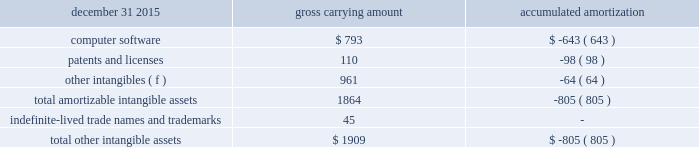December 31 , 2015 carrying amount accumulated amortization .
Computer software consists primarily of software costs associated with an enterprise business solution ( ebs ) within arconic to drive common systems among all businesses .
Amortization expense related to the intangible assets in the tables above for the years ended december 31 , 2016 , 2015 , and 2014 was $ 65 , $ 67 , and $ 55 , respectively , and is expected to be in the range of approximately $ 56 to $ 64 annually from 2017 to 2021 .
Acquisitions and divestitures pro forma results of the company , assuming all acquisitions described below were made at the beginning of the earliest prior period presented , would not have been materially different from the results reported .
2016 divestitures .
In april 2016 , arconic completed the sale of the remmele medical business to lisi medical for $ 102 in cash ( $ 99 net of transaction costs ) , which was included in proceeds from the sale of assets and businesses on the accompanying statement of consolidated cash flows .
This business , which was part of the rti international metals inc .
( rti ) acquisition ( see below ) , manufactures precision-machined metal products for customers in the minimally invasive surgical device and implantable device markets .
Since this transaction occurred within a year of the completion of the rti acquisition , no gain was recorded on this transaction as the excess of the proceeds over the carrying value of the net assets of this business was reflected as a purchase price adjustment ( decrease to goodwill of $ 44 ) to the final allocation of the purchase price related to arconic 2019s acquisition of rti .
While owned by arconic , the operating results and assets and liabilities of this business were included in the engineered products and solutions segment .
This business generated sales of approximately $ 20 from january 1 , 2016 through the divestiture date , april 29 , 2016 , and , at the time of the divestiture , had approximately 330 employees .
This transaction is no longer subject to post-closing adjustments .
2015 acquisitions .
In march 2015 , arconic completed the acquisition of an aerospace structural castings company , tital , for $ 204 ( 20ac188 ) in cash ( an additional $ 1 ( 20ac1 ) was paid in september 2015 to settle working capital in accordance with the purchase agreement ) .
Tital , a privately held company with approximately 650 employees based in germany , produces aluminum and titanium investment casting products for the aerospace and defense markets .
The purpose of this acquisition is to capture increasing demand for advanced jet engine components made of titanium , establish titanium-casting capabilities in europe , and expand existing aluminum casting capacity .
The assets , including the associated goodwill , and liabilities of this business were included within arconic 2019s engineered products and solutions segment since the date of acquisition .
Based on the preliminary allocation of the purchase price , goodwill of $ 118 was recorded for this transaction .
In the first quarter of 2016 , the allocation of the purchase price was finalized , based , in part , on the completion of a third-party valuation of certain assets acquired , resulting in a $ 1 reduction of the initial goodwill amount .
None of the $ 117 in goodwill is deductible for income tax purposes and no other intangible assets were identified .
This transaction is no longer subject to post-closing adjustments .
In july 2015 , arconic completed the acquisition of rti , a u.s .
Company that was publicly traded on the new york stock exchange under the ticker symbol 201crti . 201d arconic purchased all outstanding shares of rti common stock in a stock-for-stock transaction valued at $ 870 ( based on the $ 9.96 per share july 23 , 2015 closing price of arconic 2019s .
What is the original value of patents and licenses , in dollars? 
Rationale: the original value is calculated based upon the gross carrying amount formula , in which the carrying amount is equal to the original value mines the amortization/depreciation costs .
Computations: (110 + 98)
Answer: 208.0. 